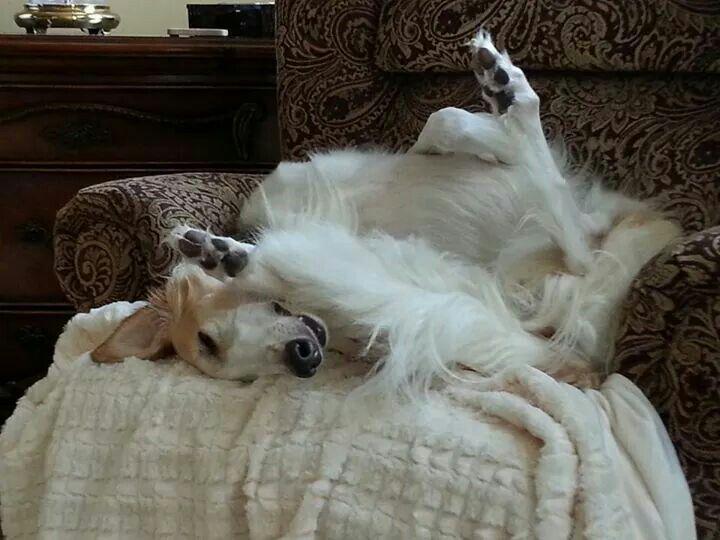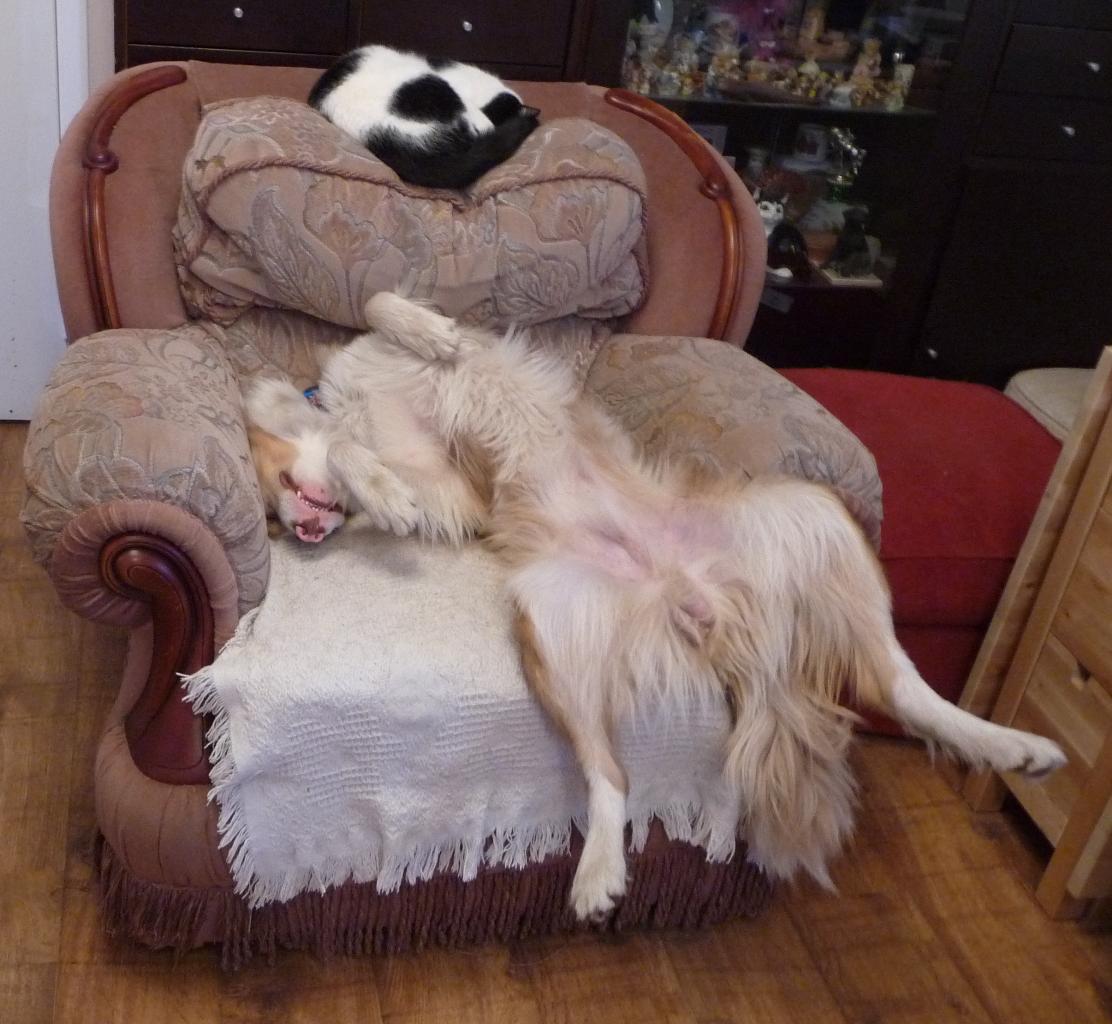The first image is the image on the left, the second image is the image on the right. For the images displayed, is the sentence "Each image shows a hound lounging on upholstered furniture, and one image shows a hound upside-down with hind legs above his front paws." factually correct? Answer yes or no. Yes. The first image is the image on the left, the second image is the image on the right. For the images displayed, is the sentence "At least one dog is laying on his back." factually correct? Answer yes or no. Yes. 